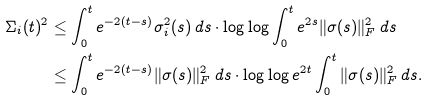Convert formula to latex. <formula><loc_0><loc_0><loc_500><loc_500>\Sigma _ { i } ( t ) ^ { 2 } & \leq \int _ { 0 } ^ { t } e ^ { - 2 ( t - s ) } \sigma _ { i } ^ { 2 } ( s ) \, d s \cdot \log \log \int _ { 0 } ^ { t } e ^ { 2 s } \| \sigma ( s ) \| ^ { 2 } _ { F } \, d s \\ & \leq \int _ { 0 } ^ { t } e ^ { - 2 ( t - s ) } \| \sigma ( s ) \| ^ { 2 } _ { F } \, d s \cdot \log \log e ^ { 2 t } \int _ { 0 } ^ { t } \| \sigma ( s ) \| ^ { 2 } _ { F } \, d s .</formula> 